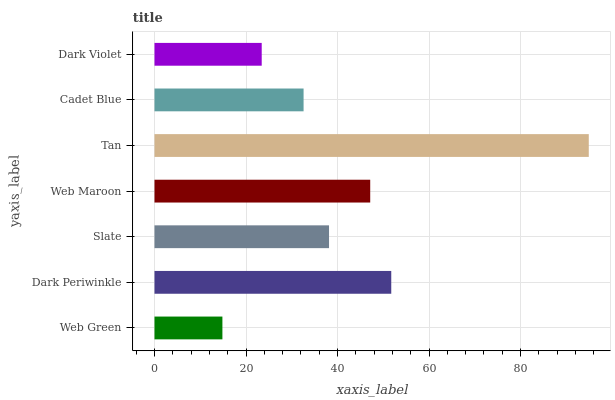Is Web Green the minimum?
Answer yes or no. Yes. Is Tan the maximum?
Answer yes or no. Yes. Is Dark Periwinkle the minimum?
Answer yes or no. No. Is Dark Periwinkle the maximum?
Answer yes or no. No. Is Dark Periwinkle greater than Web Green?
Answer yes or no. Yes. Is Web Green less than Dark Periwinkle?
Answer yes or no. Yes. Is Web Green greater than Dark Periwinkle?
Answer yes or no. No. Is Dark Periwinkle less than Web Green?
Answer yes or no. No. Is Slate the high median?
Answer yes or no. Yes. Is Slate the low median?
Answer yes or no. Yes. Is Dark Violet the high median?
Answer yes or no. No. Is Cadet Blue the low median?
Answer yes or no. No. 